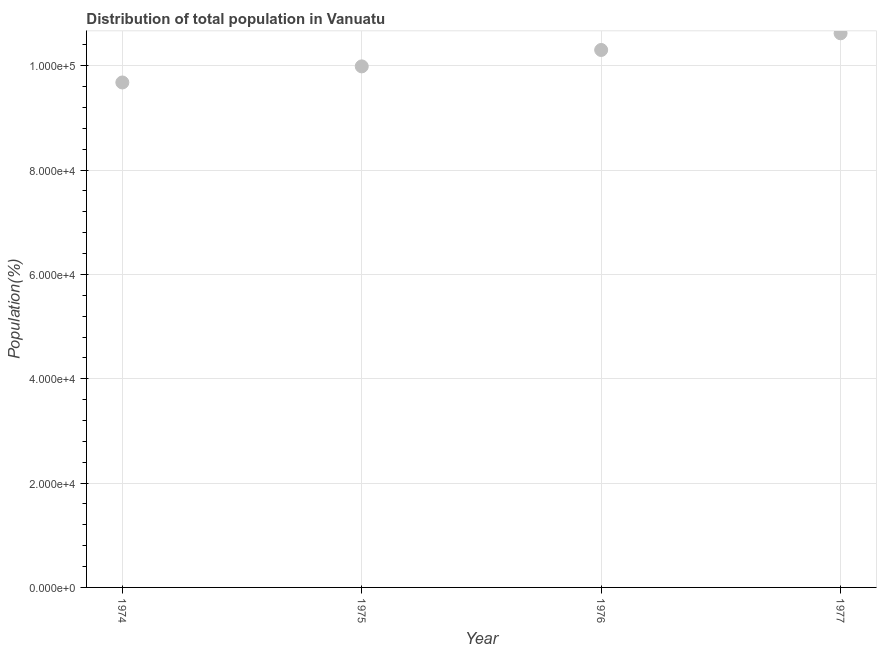What is the population in 1976?
Offer a very short reply. 1.03e+05. Across all years, what is the maximum population?
Keep it short and to the point. 1.06e+05. Across all years, what is the minimum population?
Provide a short and direct response. 9.68e+04. In which year was the population minimum?
Provide a short and direct response. 1974. What is the sum of the population?
Keep it short and to the point. 4.06e+05. What is the difference between the population in 1975 and 1977?
Offer a very short reply. -6344. What is the average population per year?
Provide a short and direct response. 1.01e+05. What is the median population?
Provide a short and direct response. 1.01e+05. In how many years, is the population greater than 12000 %?
Give a very brief answer. 4. What is the ratio of the population in 1974 to that in 1976?
Provide a short and direct response. 0.94. Is the population in 1974 less than that in 1977?
Offer a very short reply. Yes. Is the difference between the population in 1975 and 1976 greater than the difference between any two years?
Offer a very short reply. No. What is the difference between the highest and the second highest population?
Make the answer very short. 3199. Is the sum of the population in 1974 and 1976 greater than the maximum population across all years?
Your response must be concise. Yes. What is the difference between the highest and the lowest population?
Provide a short and direct response. 9430. In how many years, is the population greater than the average population taken over all years?
Keep it short and to the point. 2. Does the population monotonically increase over the years?
Offer a very short reply. Yes. How many years are there in the graph?
Ensure brevity in your answer.  4. What is the difference between two consecutive major ticks on the Y-axis?
Provide a short and direct response. 2.00e+04. Are the values on the major ticks of Y-axis written in scientific E-notation?
Your answer should be very brief. Yes. Does the graph contain grids?
Offer a terse response. Yes. What is the title of the graph?
Make the answer very short. Distribution of total population in Vanuatu . What is the label or title of the Y-axis?
Offer a very short reply. Population(%). What is the Population(%) in 1974?
Ensure brevity in your answer.  9.68e+04. What is the Population(%) in 1975?
Give a very brief answer. 9.99e+04. What is the Population(%) in 1976?
Your response must be concise. 1.03e+05. What is the Population(%) in 1977?
Offer a terse response. 1.06e+05. What is the difference between the Population(%) in 1974 and 1975?
Provide a succinct answer. -3086. What is the difference between the Population(%) in 1974 and 1976?
Provide a succinct answer. -6231. What is the difference between the Population(%) in 1974 and 1977?
Your answer should be compact. -9430. What is the difference between the Population(%) in 1975 and 1976?
Make the answer very short. -3145. What is the difference between the Population(%) in 1975 and 1977?
Provide a succinct answer. -6344. What is the difference between the Population(%) in 1976 and 1977?
Offer a terse response. -3199. What is the ratio of the Population(%) in 1974 to that in 1975?
Your response must be concise. 0.97. What is the ratio of the Population(%) in 1974 to that in 1977?
Provide a short and direct response. 0.91. What is the ratio of the Population(%) in 1976 to that in 1977?
Make the answer very short. 0.97. 